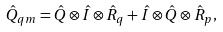Convert formula to latex. <formula><loc_0><loc_0><loc_500><loc_500>\hat { Q } _ { q m } = \hat { Q } \otimes \hat { I } \otimes \hat { R } _ { q } + \hat { I } \otimes \hat { Q } \otimes \hat { R } _ { p } ,</formula> 